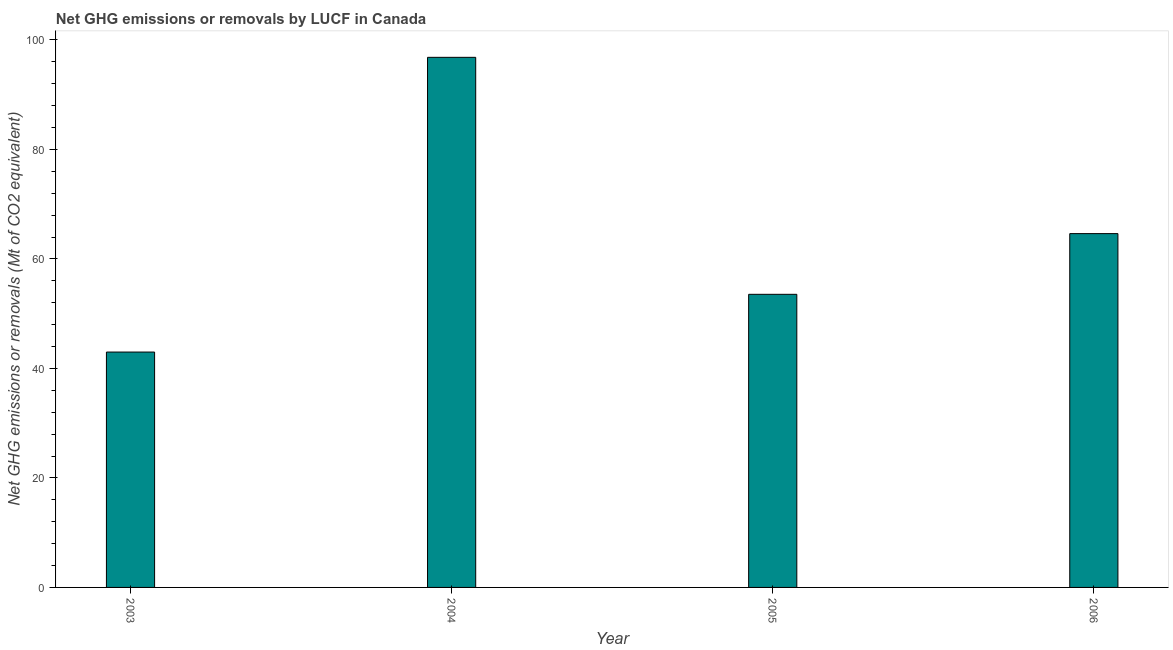Does the graph contain grids?
Your answer should be very brief. No. What is the title of the graph?
Offer a very short reply. Net GHG emissions or removals by LUCF in Canada. What is the label or title of the Y-axis?
Make the answer very short. Net GHG emissions or removals (Mt of CO2 equivalent). What is the ghg net emissions or removals in 2005?
Give a very brief answer. 53.53. Across all years, what is the maximum ghg net emissions or removals?
Your response must be concise. 96.82. Across all years, what is the minimum ghg net emissions or removals?
Make the answer very short. 42.99. What is the sum of the ghg net emissions or removals?
Offer a terse response. 257.96. What is the difference between the ghg net emissions or removals in 2004 and 2005?
Offer a very short reply. 43.28. What is the average ghg net emissions or removals per year?
Your answer should be compact. 64.49. What is the median ghg net emissions or removals?
Ensure brevity in your answer.  59.08. What is the ratio of the ghg net emissions or removals in 2003 to that in 2005?
Offer a very short reply. 0.8. What is the difference between the highest and the second highest ghg net emissions or removals?
Keep it short and to the point. 32.2. What is the difference between the highest and the lowest ghg net emissions or removals?
Keep it short and to the point. 53.83. How many bars are there?
Provide a short and direct response. 4. How many years are there in the graph?
Offer a terse response. 4. What is the Net GHG emissions or removals (Mt of CO2 equivalent) in 2003?
Provide a succinct answer. 42.99. What is the Net GHG emissions or removals (Mt of CO2 equivalent) of 2004?
Your answer should be very brief. 96.82. What is the Net GHG emissions or removals (Mt of CO2 equivalent) of 2005?
Make the answer very short. 53.53. What is the Net GHG emissions or removals (Mt of CO2 equivalent) in 2006?
Your answer should be very brief. 64.62. What is the difference between the Net GHG emissions or removals (Mt of CO2 equivalent) in 2003 and 2004?
Offer a very short reply. -53.83. What is the difference between the Net GHG emissions or removals (Mt of CO2 equivalent) in 2003 and 2005?
Your answer should be compact. -10.54. What is the difference between the Net GHG emissions or removals (Mt of CO2 equivalent) in 2003 and 2006?
Keep it short and to the point. -21.63. What is the difference between the Net GHG emissions or removals (Mt of CO2 equivalent) in 2004 and 2005?
Offer a very short reply. 43.29. What is the difference between the Net GHG emissions or removals (Mt of CO2 equivalent) in 2004 and 2006?
Give a very brief answer. 32.2. What is the difference between the Net GHG emissions or removals (Mt of CO2 equivalent) in 2005 and 2006?
Offer a terse response. -11.09. What is the ratio of the Net GHG emissions or removals (Mt of CO2 equivalent) in 2003 to that in 2004?
Keep it short and to the point. 0.44. What is the ratio of the Net GHG emissions or removals (Mt of CO2 equivalent) in 2003 to that in 2005?
Provide a succinct answer. 0.8. What is the ratio of the Net GHG emissions or removals (Mt of CO2 equivalent) in 2003 to that in 2006?
Offer a very short reply. 0.67. What is the ratio of the Net GHG emissions or removals (Mt of CO2 equivalent) in 2004 to that in 2005?
Make the answer very short. 1.81. What is the ratio of the Net GHG emissions or removals (Mt of CO2 equivalent) in 2004 to that in 2006?
Make the answer very short. 1.5. What is the ratio of the Net GHG emissions or removals (Mt of CO2 equivalent) in 2005 to that in 2006?
Make the answer very short. 0.83. 